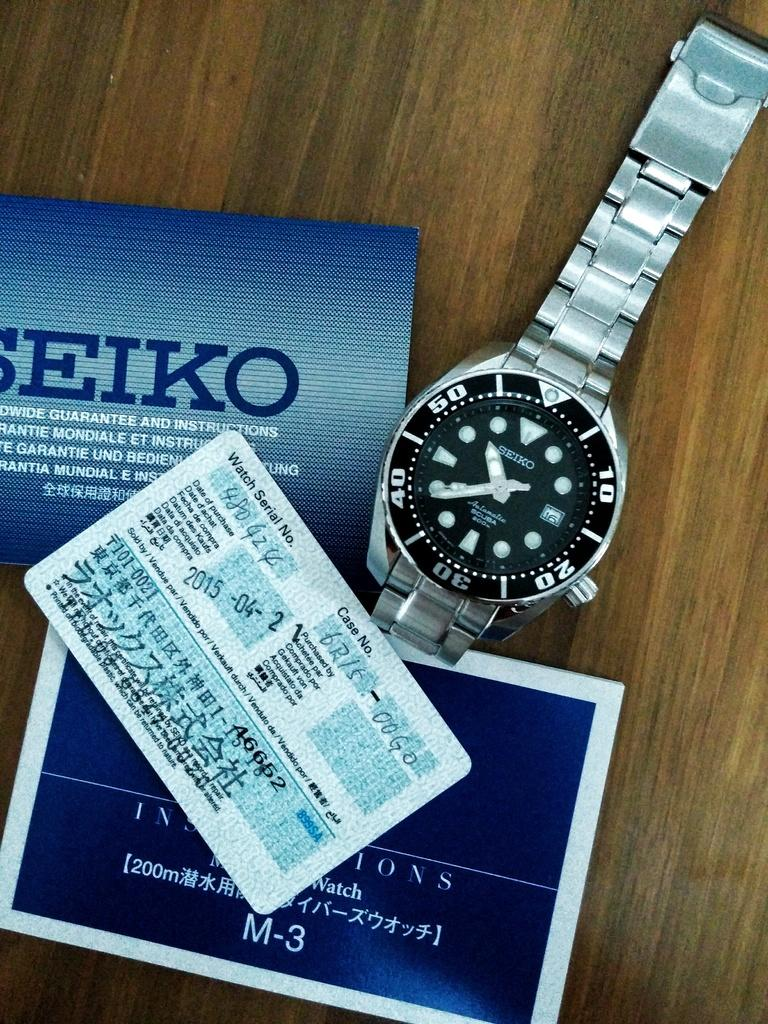<image>
Present a compact description of the photo's key features. A Seiko watch with a black face sits next to a box and certificate. 